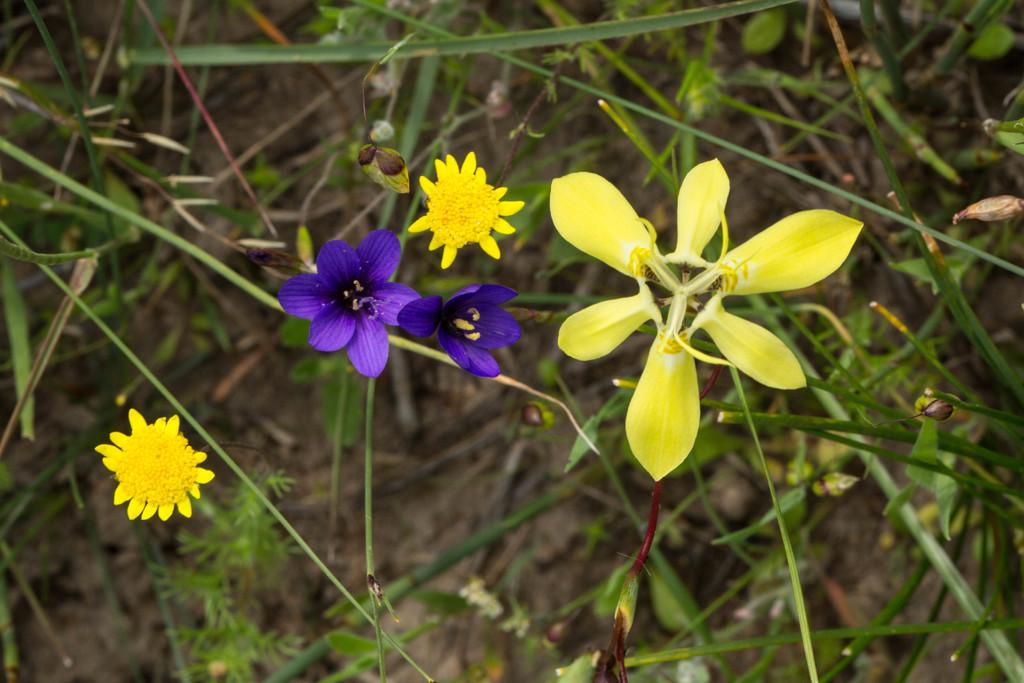What colors are the flowers in the image? The flowers in the image are yellow and purple. Can you describe the plants visible in the background of the image? Unfortunately, the provided facts do not mention any specific details about the plants in the background. How many different types of flowers are present in the image? There are two types of flowers in the image: yellow and purple. What type of wood is used to make the baseball bat in the image? There is no baseball bat present in the image; it features yellow and purple flowers and plants in the background. 